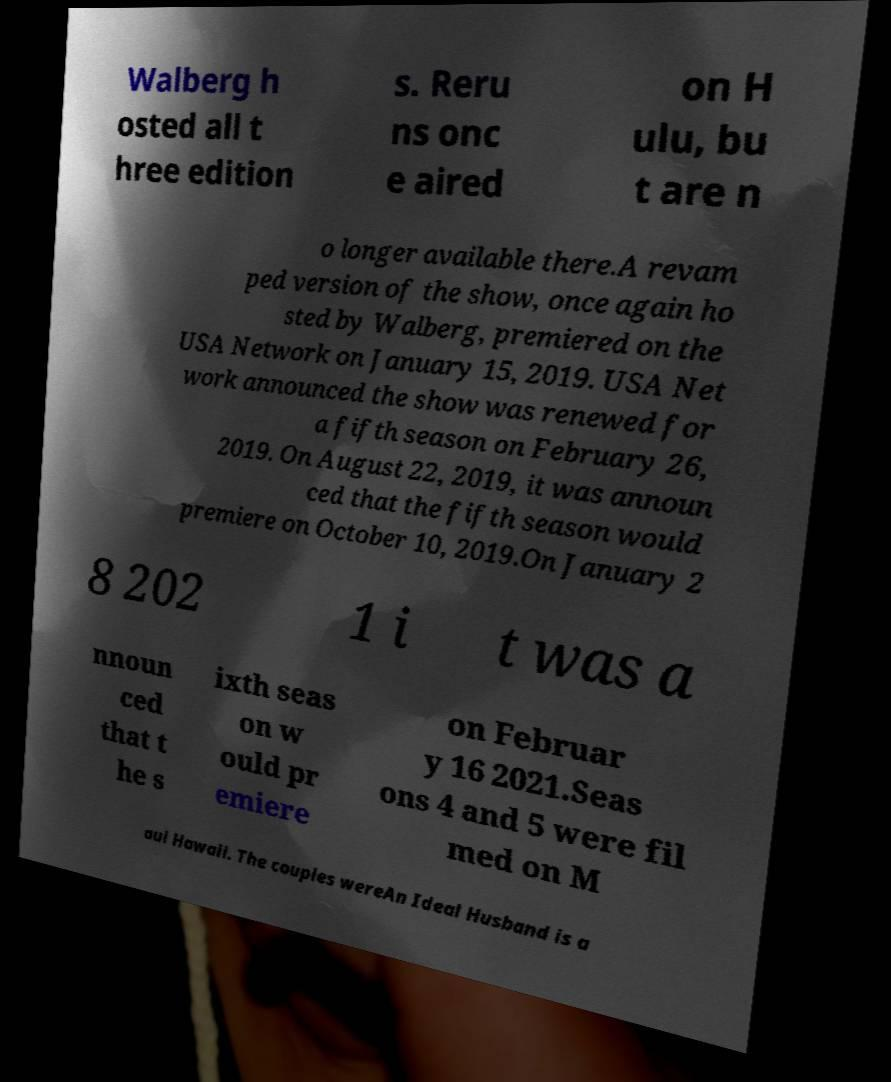Please identify and transcribe the text found in this image. Walberg h osted all t hree edition s. Reru ns onc e aired on H ulu, bu t are n o longer available there.A revam ped version of the show, once again ho sted by Walberg, premiered on the USA Network on January 15, 2019. USA Net work announced the show was renewed for a fifth season on February 26, 2019. On August 22, 2019, it was announ ced that the fifth season would premiere on October 10, 2019.On January 2 8 202 1 i t was a nnoun ced that t he s ixth seas on w ould pr emiere on Februar y 16 2021.Seas ons 4 and 5 were fil med on M aui Hawaii. The couples wereAn Ideal Husband is a 